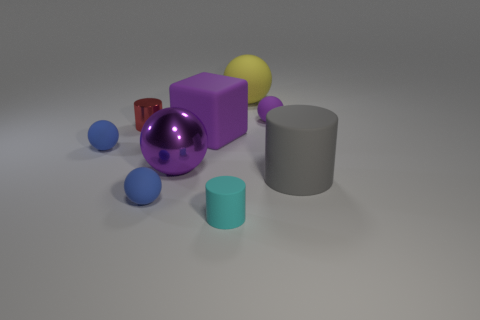What is the material of the small red cylinder?
Give a very brief answer. Metal. What is the shape of the object that is made of the same material as the big purple ball?
Your answer should be very brief. Cylinder. How many other things are the same shape as the cyan object?
Provide a short and direct response. 2. How many purple blocks are in front of the large cylinder?
Offer a terse response. 0. Do the blue matte ball that is in front of the big purple sphere and the purple sphere on the left side of the tiny cyan cylinder have the same size?
Your response must be concise. No. How many other objects are there of the same size as the cyan object?
Your response must be concise. 4. The large sphere on the left side of the purple matte thing on the left side of the cylinder in front of the gray thing is made of what material?
Give a very brief answer. Metal. There is a gray cylinder; is its size the same as the blue rubber thing that is to the right of the small red metal cylinder?
Your response must be concise. No. There is a rubber thing that is on the right side of the big rubber ball and behind the purple metal sphere; how big is it?
Your answer should be very brief. Small. Are there any things that have the same color as the large rubber sphere?
Your answer should be compact. No. 